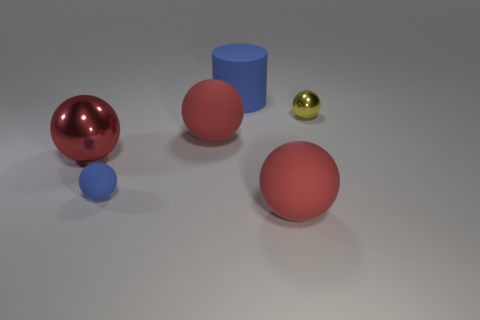Subtract all red spheres. How many were subtracted if there are1red spheres left? 2 Subtract all small yellow shiny balls. How many balls are left? 4 Add 1 blue rubber cylinders. How many objects exist? 7 Subtract all yellow balls. How many balls are left? 4 Subtract 1 spheres. How many spheres are left? 4 Add 5 big green rubber spheres. How many big green rubber spheres exist? 5 Subtract 1 yellow spheres. How many objects are left? 5 Subtract all cylinders. How many objects are left? 5 Subtract all red cylinders. Subtract all green cubes. How many cylinders are left? 1 Subtract all cyan cylinders. How many red balls are left? 3 